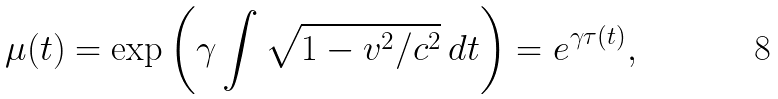<formula> <loc_0><loc_0><loc_500><loc_500>\mu ( t ) = \exp { \left ( \gamma \int \sqrt { 1 - v ^ { 2 } / c ^ { 2 } } \, d t \right ) } = e ^ { \gamma \tau ( t ) } ,</formula> 